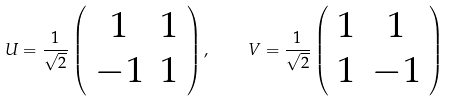<formula> <loc_0><loc_0><loc_500><loc_500>U = \frac { 1 } { \sqrt { 2 } } \left ( \begin{array} { c c } 1 & 1 \\ - 1 & 1 \end{array} \right ) , \quad V = \frac { 1 } { \sqrt { 2 } } \left ( \begin{array} { c c } 1 & 1 \\ 1 & - 1 \end{array} \right )</formula> 